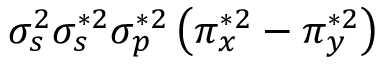<formula> <loc_0><loc_0><loc_500><loc_500>\sigma _ { s } ^ { 2 } \sigma _ { s } ^ { * 2 } \sigma _ { p } ^ { * 2 } \left ( \pi _ { x } ^ { * 2 } - \pi _ { y } ^ { * 2 } \right )</formula> 